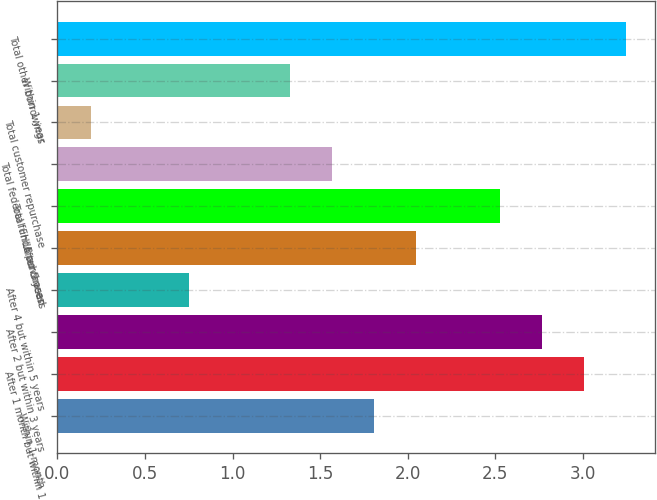<chart> <loc_0><loc_0><loc_500><loc_500><bar_chart><fcel>Within 1 month<fcel>After 1 month but within 1<fcel>After 2 but within 3 years<fcel>After 4 but within 5 years<fcel>After 5 years<fcel>Total FHLB advances<fcel>Total federal funds purchased<fcel>Total customer repurchase<fcel>Within 1 year<fcel>Total other borrowings<nl><fcel>1.81<fcel>3.01<fcel>2.77<fcel>0.75<fcel>2.05<fcel>2.53<fcel>1.57<fcel>0.19<fcel>1.33<fcel>3.25<nl></chart> 